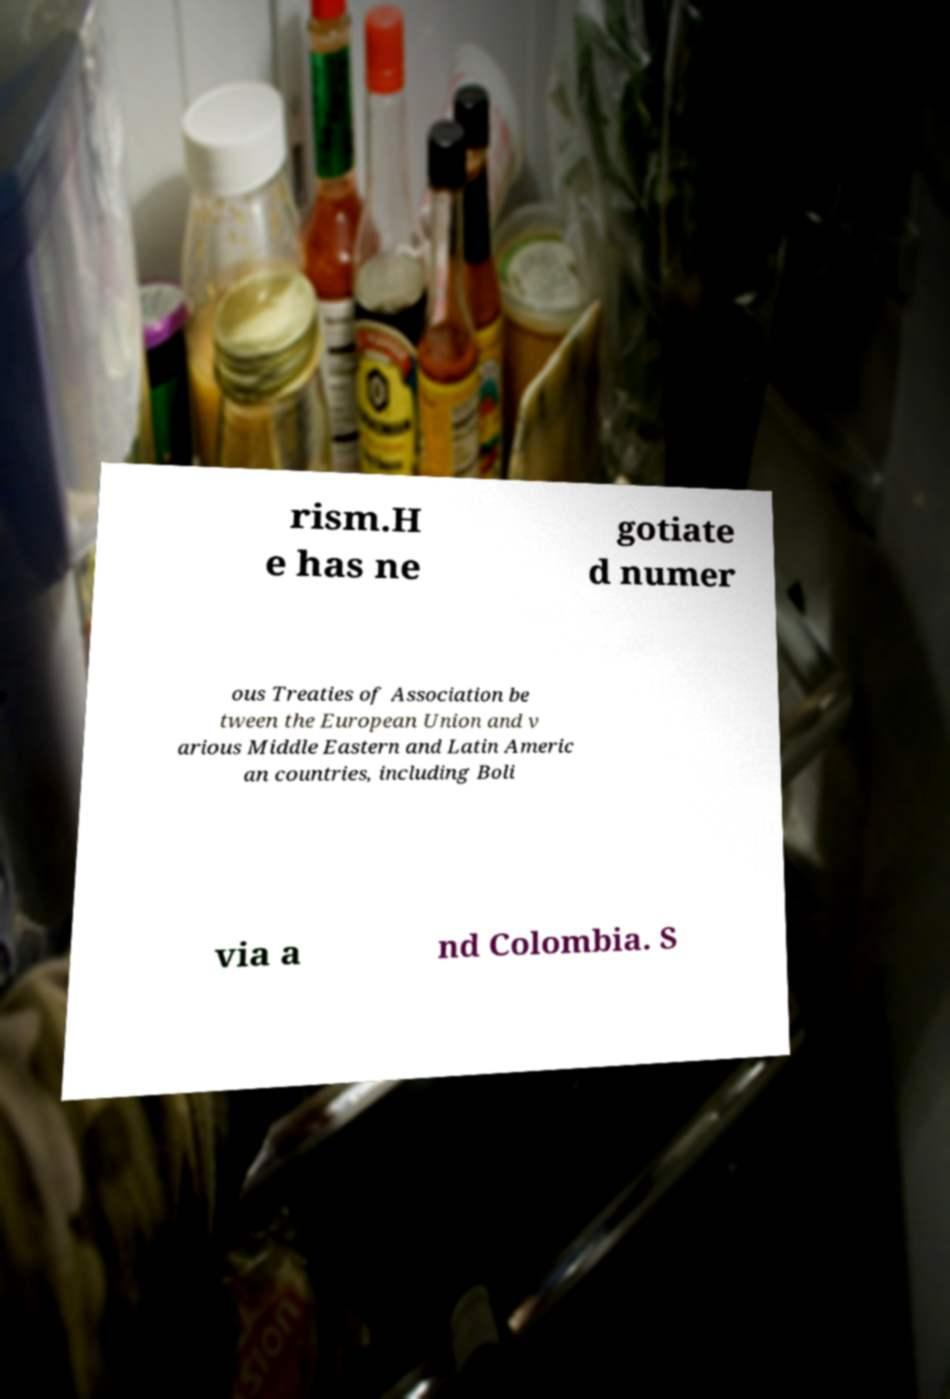What messages or text are displayed in this image? I need them in a readable, typed format. rism.H e has ne gotiate d numer ous Treaties of Association be tween the European Union and v arious Middle Eastern and Latin Americ an countries, including Boli via a nd Colombia. S 